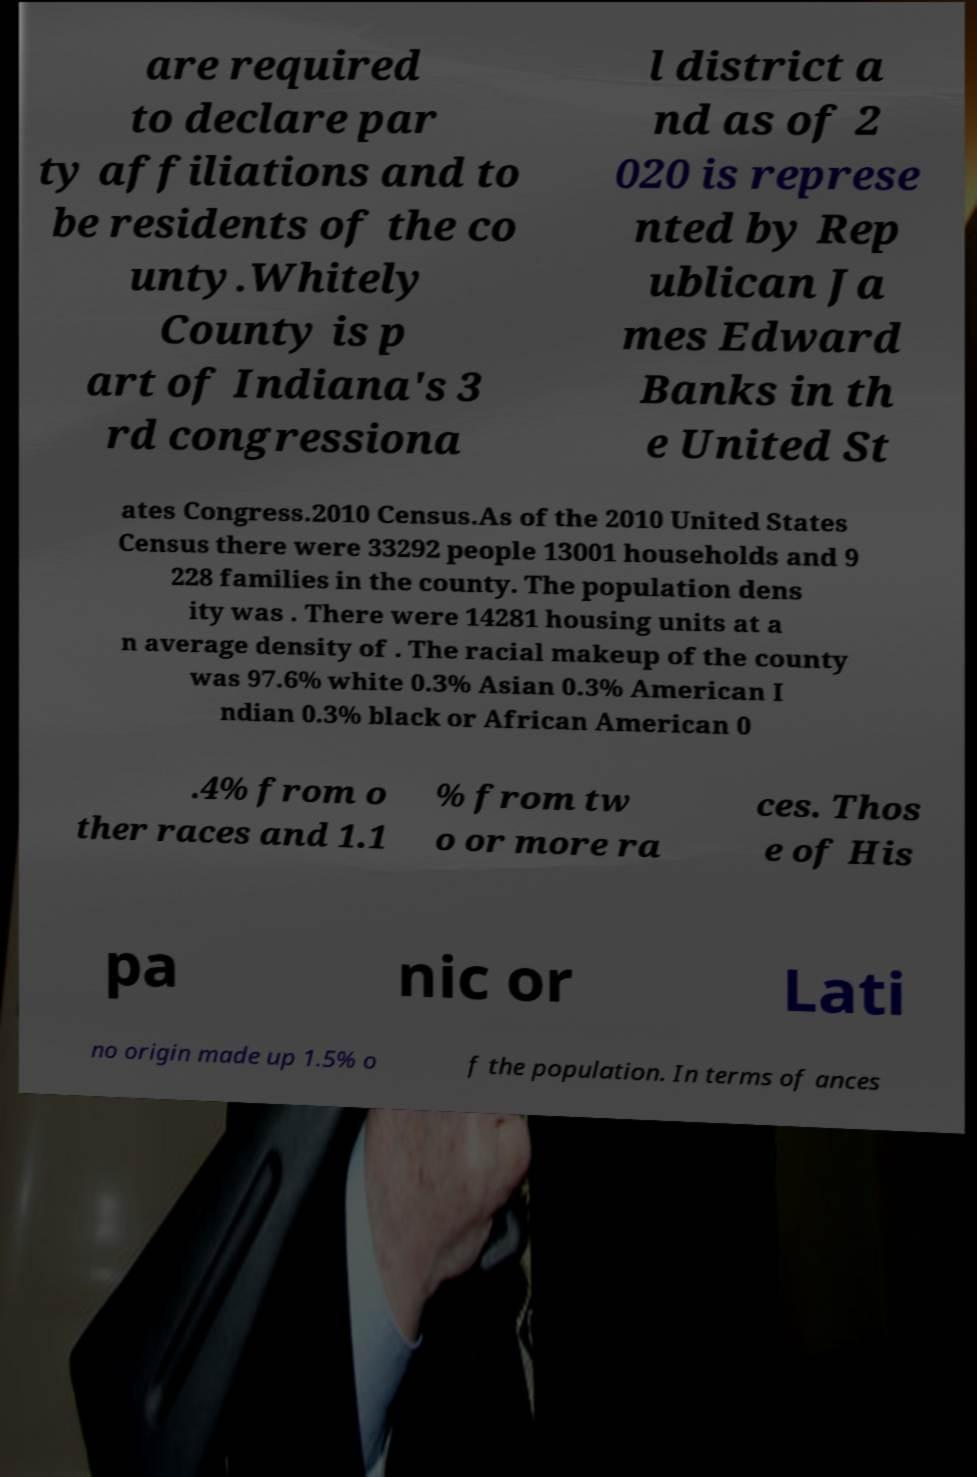Please read and relay the text visible in this image. What does it say? are required to declare par ty affiliations and to be residents of the co unty.Whitely County is p art of Indiana's 3 rd congressiona l district a nd as of 2 020 is represe nted by Rep ublican Ja mes Edward Banks in th e United St ates Congress.2010 Census.As of the 2010 United States Census there were 33292 people 13001 households and 9 228 families in the county. The population dens ity was . There were 14281 housing units at a n average density of . The racial makeup of the county was 97.6% white 0.3% Asian 0.3% American I ndian 0.3% black or African American 0 .4% from o ther races and 1.1 % from tw o or more ra ces. Thos e of His pa nic or Lati no origin made up 1.5% o f the population. In terms of ances 